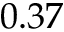Convert formula to latex. <formula><loc_0><loc_0><loc_500><loc_500>0 . 3 7</formula> 